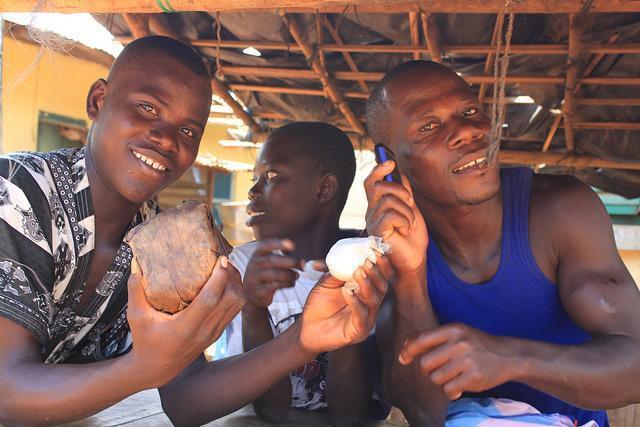How many people are in this photo?
Give a very brief answer. 3. How many people are in the picture?
Give a very brief answer. 3. 